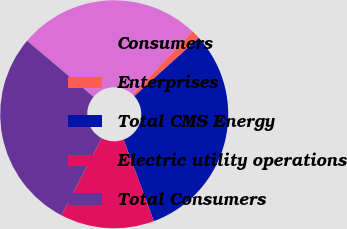Convert chart. <chart><loc_0><loc_0><loc_500><loc_500><pie_chart><fcel>Consumers<fcel>Enterprises<fcel>Total CMS Energy<fcel>Electric utility operations<fcel>Total Consumers<nl><fcel>25.88%<fcel>1.28%<fcel>31.05%<fcel>13.32%<fcel>28.47%<nl></chart> 